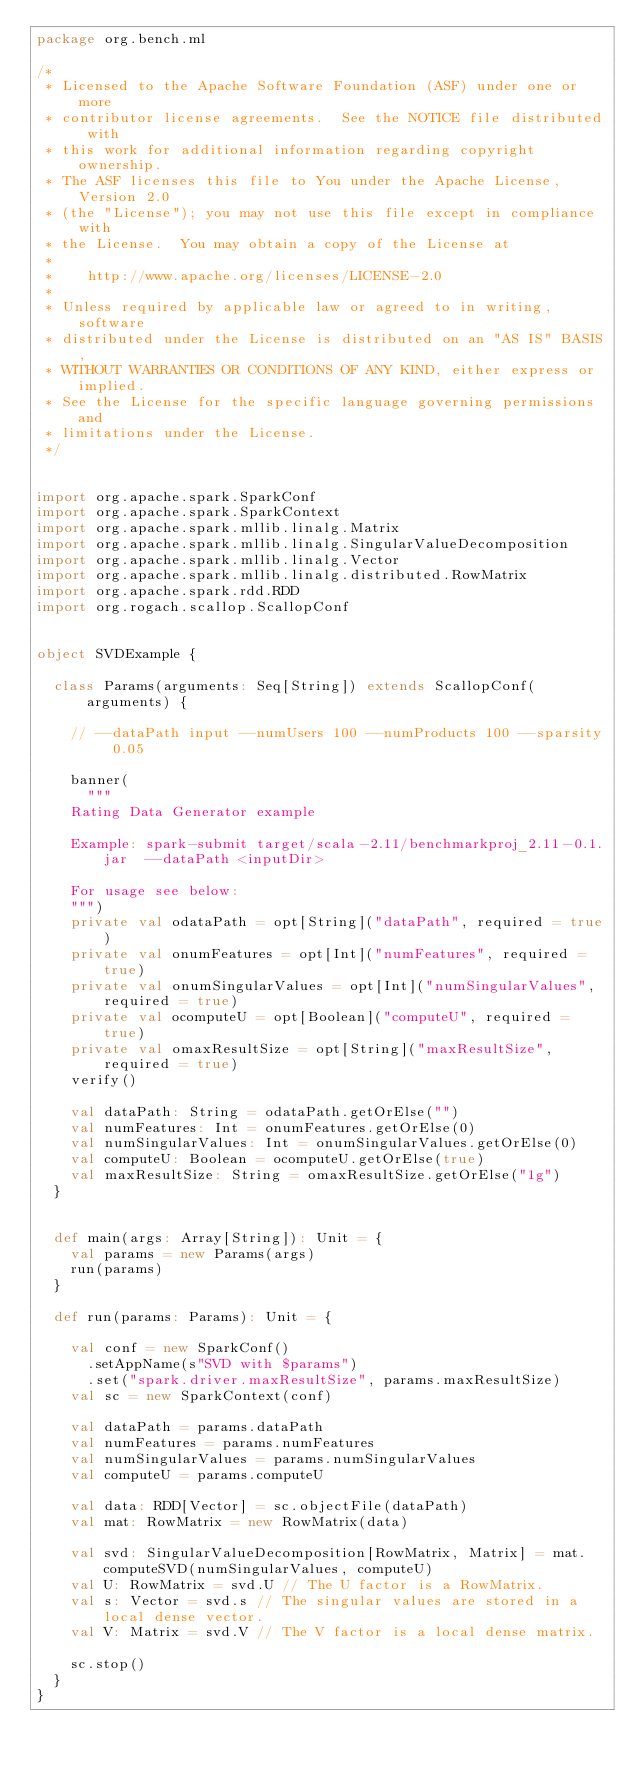Convert code to text. <code><loc_0><loc_0><loc_500><loc_500><_Scala_>package org.bench.ml

/*
 * Licensed to the Apache Software Foundation (ASF) under one or more
 * contributor license agreements.  See the NOTICE file distributed with
 * this work for additional information regarding copyright ownership.
 * The ASF licenses this file to You under the Apache License, Version 2.0
 * (the "License"); you may not use this file except in compliance with
 * the License.  You may obtain a copy of the License at
 *
 *    http://www.apache.org/licenses/LICENSE-2.0
 *
 * Unless required by applicable law or agreed to in writing, software
 * distributed under the License is distributed on an "AS IS" BASIS,
 * WITHOUT WARRANTIES OR CONDITIONS OF ANY KIND, either express or implied.
 * See the License for the specific language governing permissions and
 * limitations under the License.
 */


import org.apache.spark.SparkConf
import org.apache.spark.SparkContext
import org.apache.spark.mllib.linalg.Matrix
import org.apache.spark.mllib.linalg.SingularValueDecomposition
import org.apache.spark.mllib.linalg.Vector
import org.apache.spark.mllib.linalg.distributed.RowMatrix
import org.apache.spark.rdd.RDD
import org.rogach.scallop.ScallopConf


object SVDExample {

  class Params(arguments: Seq[String]) extends ScallopConf(arguments) {

    // --dataPath input --numUsers 100 --numProducts 100 --sparsity 0.05

    banner(
      """
    Rating Data Generator example

    Example: spark-submit target/scala-2.11/benchmarkproj_2.11-0.1.jar  --dataPath <inputDir>

    For usage see below:
    """)
    private val odataPath = opt[String]("dataPath", required = true)
    private val onumFeatures = opt[Int]("numFeatures", required = true)
    private val onumSingularValues = opt[Int]("numSingularValues", required = true)
    private val ocomputeU = opt[Boolean]("computeU", required = true)
    private val omaxResultSize = opt[String]("maxResultSize", required = true)
    verify()

    val dataPath: String = odataPath.getOrElse("")
    val numFeatures: Int = onumFeatures.getOrElse(0)
    val numSingularValues: Int = onumSingularValues.getOrElse(0)
    val computeU: Boolean = ocomputeU.getOrElse(true)
    val maxResultSize: String = omaxResultSize.getOrElse("1g")
  }


  def main(args: Array[String]): Unit = {
    val params = new Params(args)
    run(params)
  }

  def run(params: Params): Unit = {

    val conf = new SparkConf()
      .setAppName(s"SVD with $params")
      .set("spark.driver.maxResultSize", params.maxResultSize)
    val sc = new SparkContext(conf)

    val dataPath = params.dataPath
    val numFeatures = params.numFeatures
    val numSingularValues = params.numSingularValues
    val computeU = params.computeU

    val data: RDD[Vector] = sc.objectFile(dataPath)
    val mat: RowMatrix = new RowMatrix(data)

    val svd: SingularValueDecomposition[RowMatrix, Matrix] = mat.computeSVD(numSingularValues, computeU)
    val U: RowMatrix = svd.U // The U factor is a RowMatrix.
    val s: Vector = svd.s // The singular values are stored in a local dense vector.
    val V: Matrix = svd.V // The V factor is a local dense matrix.

    sc.stop()
  }
}
</code> 